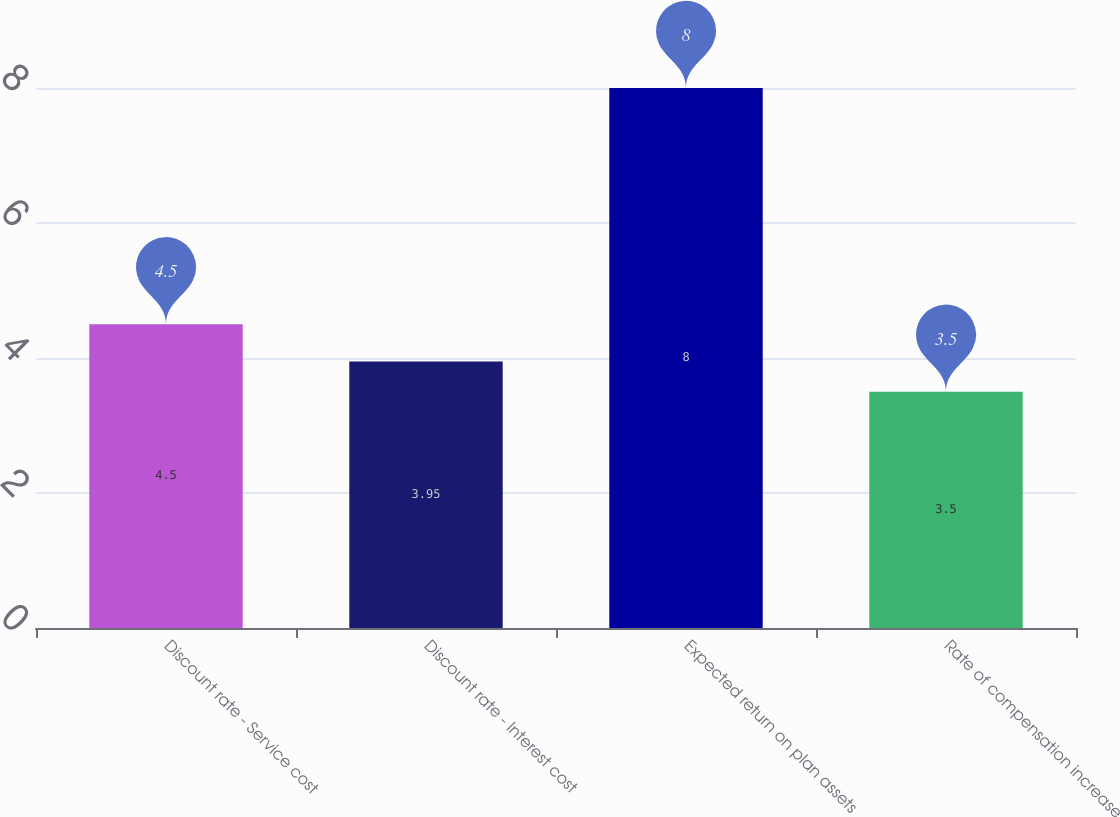Convert chart to OTSL. <chart><loc_0><loc_0><loc_500><loc_500><bar_chart><fcel>Discount rate - Service cost<fcel>Discount rate - Interest cost<fcel>Expected return on plan assets<fcel>Rate of compensation increase<nl><fcel>4.5<fcel>3.95<fcel>8<fcel>3.5<nl></chart> 